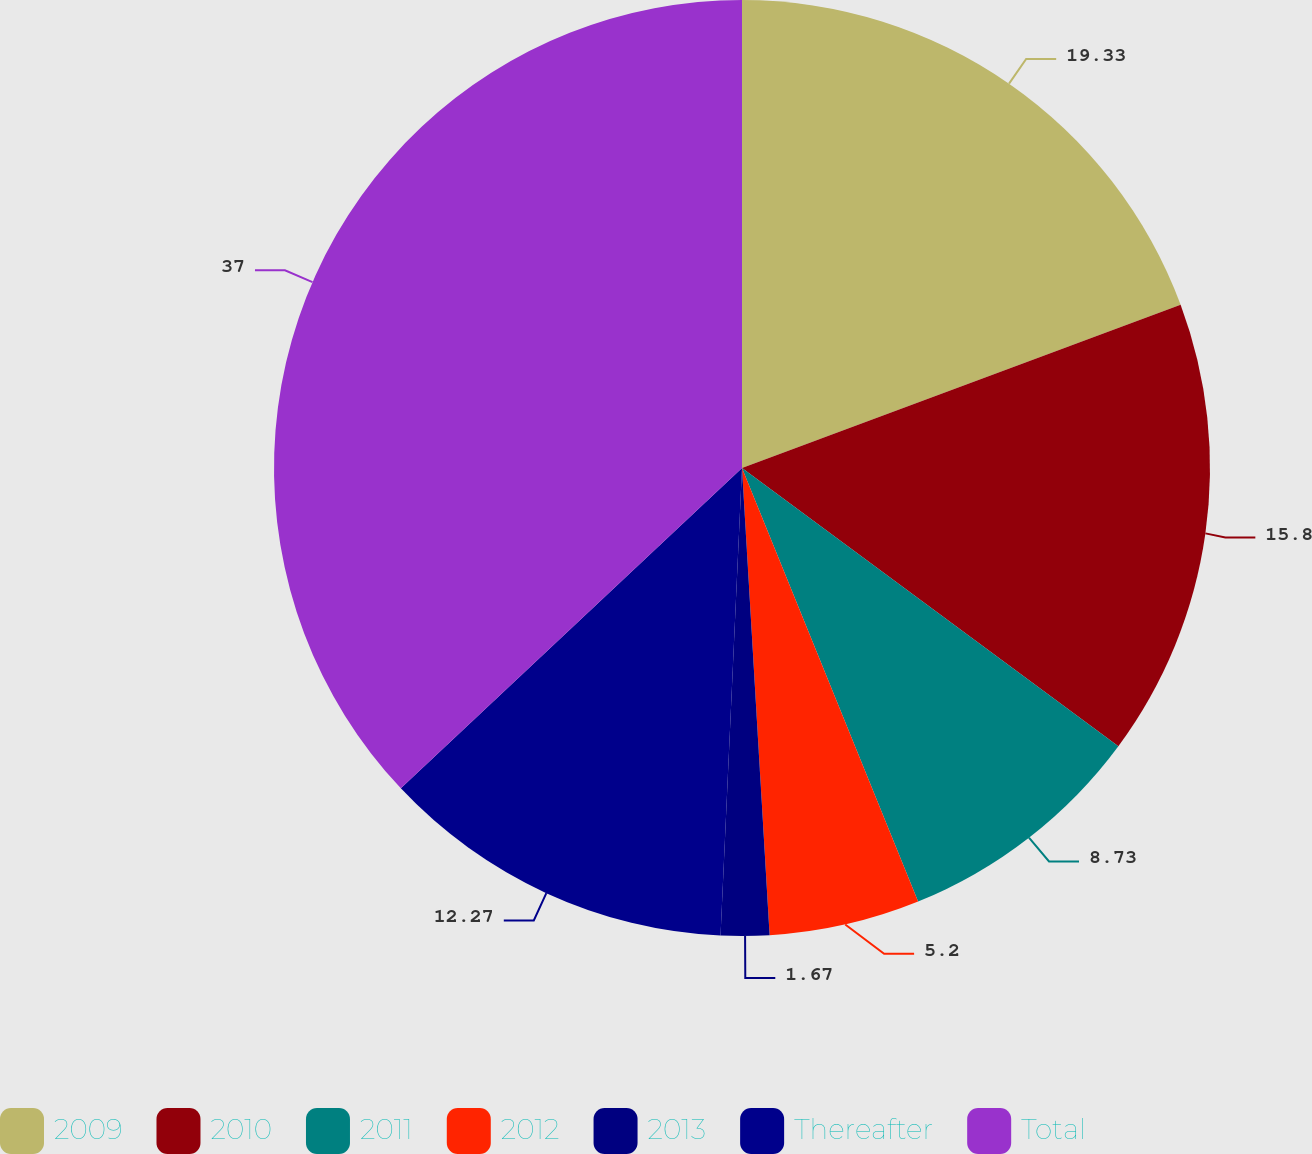Convert chart to OTSL. <chart><loc_0><loc_0><loc_500><loc_500><pie_chart><fcel>2009<fcel>2010<fcel>2011<fcel>2012<fcel>2013<fcel>Thereafter<fcel>Total<nl><fcel>19.33%<fcel>15.8%<fcel>8.73%<fcel>5.2%<fcel>1.67%<fcel>12.27%<fcel>37.0%<nl></chart> 